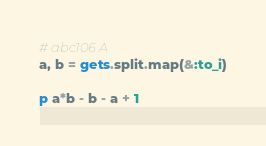<code> <loc_0><loc_0><loc_500><loc_500><_Ruby_># abc106 A
a, b = gets.split.map(&:to_i)

p a*b - b - a + 1

</code> 